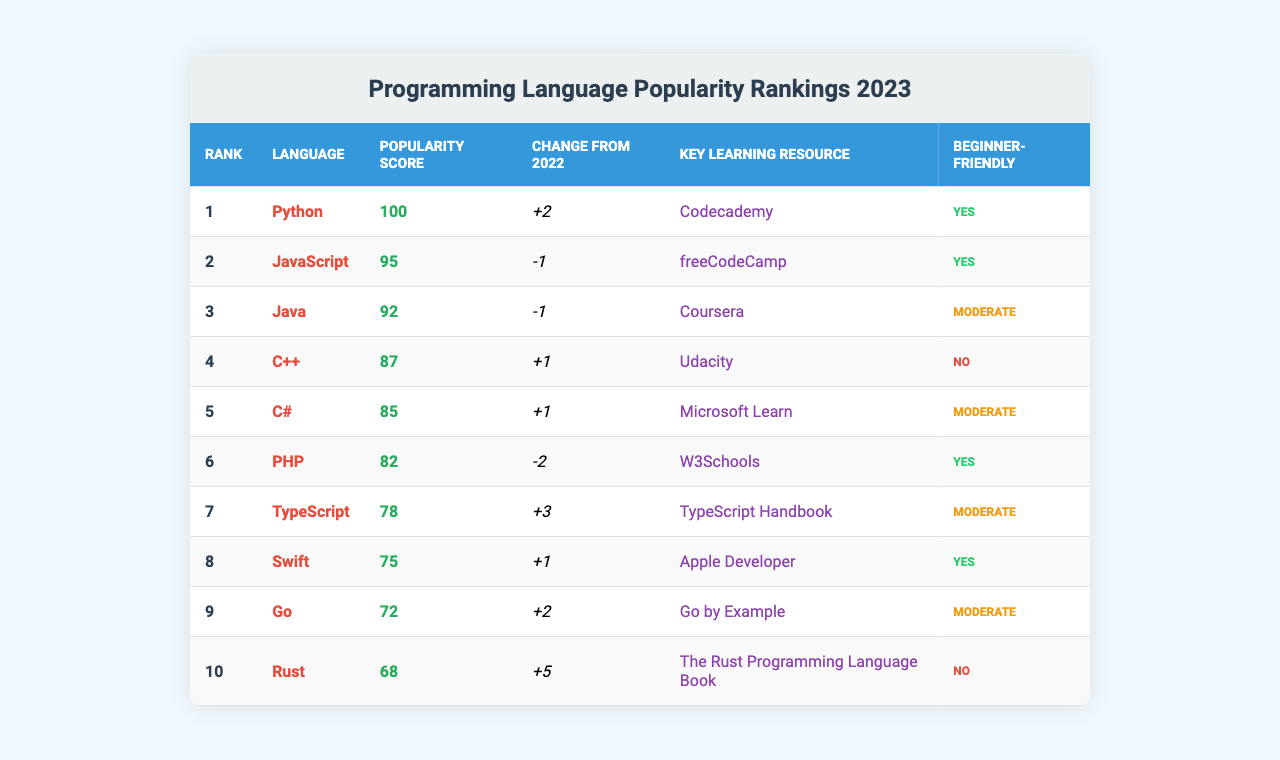What programming language has the highest popularity score in 2023? Python is listed as the top programming language with a popularity score of 100, as seen in the rank column of the table.
Answer: Python Which programming language experienced the largest positive change from 2022? Rust showed the largest positive change, increasing by +5 from its 2022 position, based on the change column data.
Answer: Rust How many programming languages are classified as beginner-friendly? By counting the "Yes" entries in the "Beginner-Friendly" column, there are 5 programming languages that are classified as beginner-friendly.
Answer: 5 What is the popularity score of JavaScript? JavaScript has a popularity score of 95, as indicated in the table under the popularity score column.
Answer: 95 Which programming language has a popularity score lower than C#, and what is that score? PHP is the language with a score lower than C# (which has 85), and it has a popularity score of 82.
Answer: PHP, 82 If we consider the average popularity score of all languages, what is it? The total popularity score across all languages is calculated as 100 + 95 + 92 + 87 + 85 + 82 + 78 + 75 + 72 + 68 =  929. There are 10 languages, so the average is 929 / 10 = 92.9.
Answer: 92.9 Does any programming language have a learning resource that is free? Yes, both Python and PHP offer free learning resources: Codecademy and W3Schools, respectively, as indicated in the "Key Learning Resource" column.
Answer: Yes What is the change in popularity score for Go compared to Java? Go has a positive change of +2, while Java had a negative change of -1, making Go’s net change +3 relative to Java when considering both languages' changes.
Answer: +3 How many programming languages are there that have a popularity score ending in a "2"? There are 3 languages whose popularity scores end in "2": PHP (82), Go (72), and C# (85).
Answer: 2 Is TypeScript classified as beginner-friendly? Yes, TypeScript is classified as beginner-friendly, as indicated by "Yes" in the "Beginner-Friendly" column.
Answer: Yes 